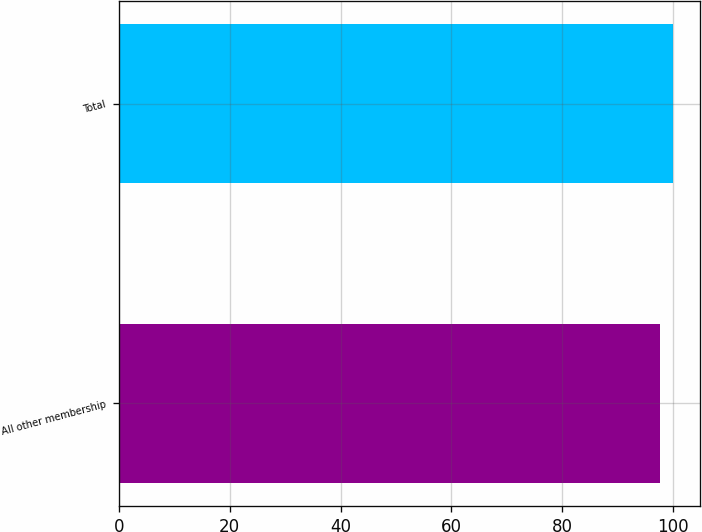Convert chart. <chart><loc_0><loc_0><loc_500><loc_500><bar_chart><fcel>All other membership<fcel>Total<nl><fcel>97.7<fcel>100<nl></chart> 